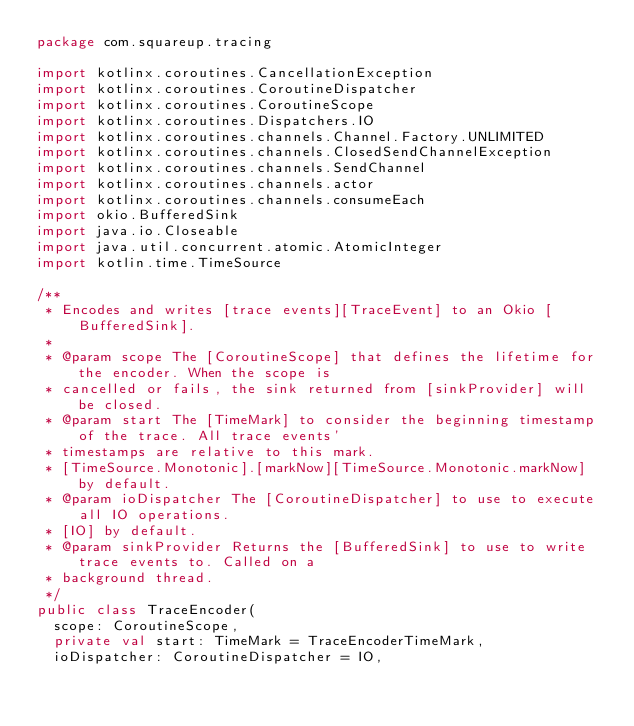Convert code to text. <code><loc_0><loc_0><loc_500><loc_500><_Kotlin_>package com.squareup.tracing

import kotlinx.coroutines.CancellationException
import kotlinx.coroutines.CoroutineDispatcher
import kotlinx.coroutines.CoroutineScope
import kotlinx.coroutines.Dispatchers.IO
import kotlinx.coroutines.channels.Channel.Factory.UNLIMITED
import kotlinx.coroutines.channels.ClosedSendChannelException
import kotlinx.coroutines.channels.SendChannel
import kotlinx.coroutines.channels.actor
import kotlinx.coroutines.channels.consumeEach
import okio.BufferedSink
import java.io.Closeable
import java.util.concurrent.atomic.AtomicInteger
import kotlin.time.TimeSource

/**
 * Encodes and writes [trace events][TraceEvent] to an Okio [BufferedSink].
 *
 * @param scope The [CoroutineScope] that defines the lifetime for the encoder. When the scope is
 * cancelled or fails, the sink returned from [sinkProvider] will be closed.
 * @param start The [TimeMark] to consider the beginning timestamp of the trace. All trace events'
 * timestamps are relative to this mark.
 * [TimeSource.Monotonic].[markNow][TimeSource.Monotonic.markNow] by default.
 * @param ioDispatcher The [CoroutineDispatcher] to use to execute all IO operations.
 * [IO] by default.
 * @param sinkProvider Returns the [BufferedSink] to use to write trace events to. Called on a
 * background thread.
 */
public class TraceEncoder(
  scope: CoroutineScope,
  private val start: TimeMark = TraceEncoderTimeMark,
  ioDispatcher: CoroutineDispatcher = IO,</code> 